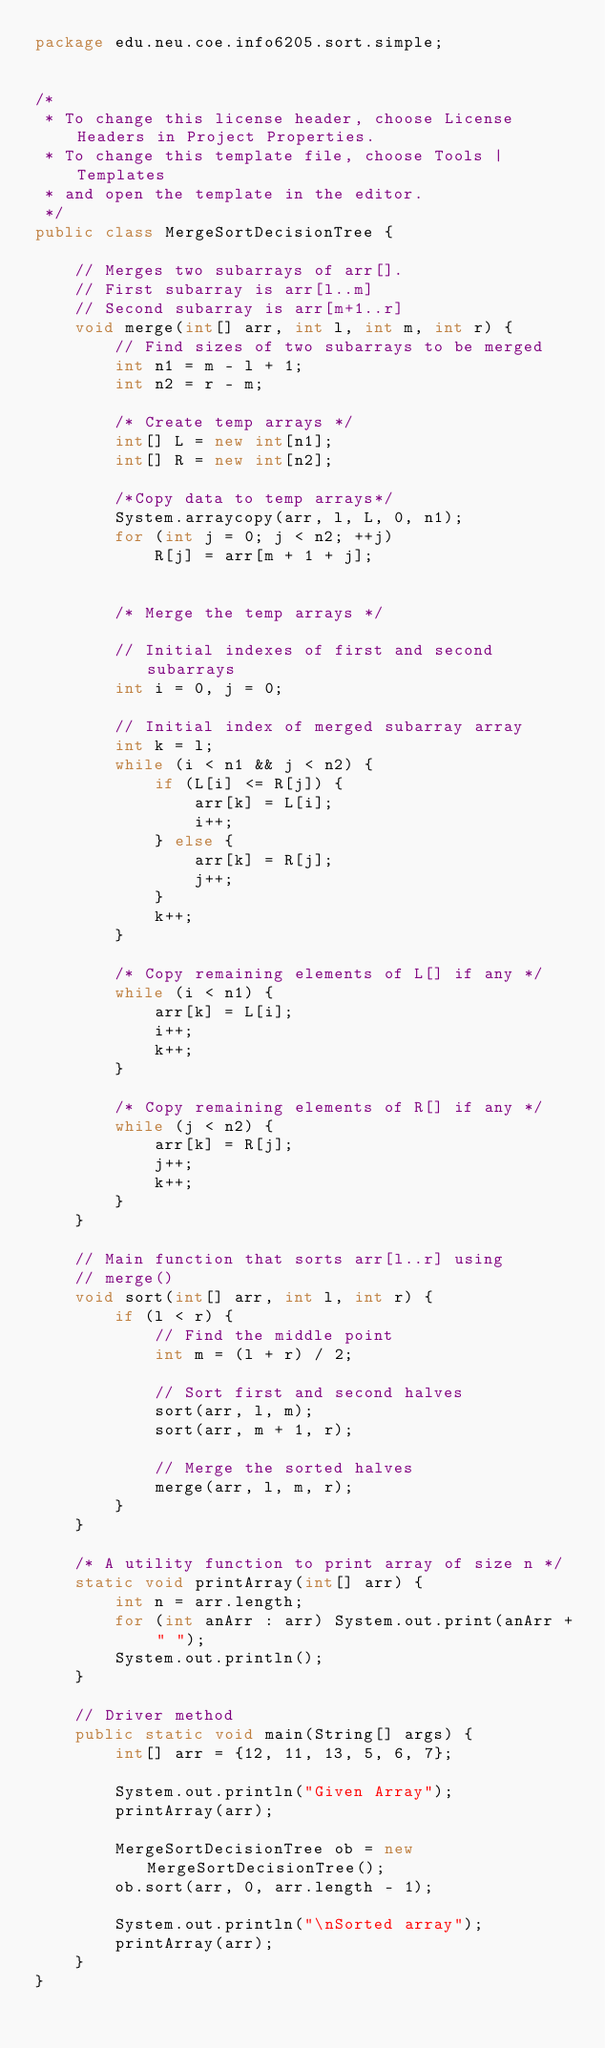<code> <loc_0><loc_0><loc_500><loc_500><_Java_>package edu.neu.coe.info6205.sort.simple;


/*
 * To change this license header, choose License Headers in Project Properties.
 * To change this template file, choose Tools | Templates
 * and open the template in the editor.
 */
public class MergeSortDecisionTree {

    // Merges two subarrays of arr[].
    // First subarray is arr[l..m]
    // Second subarray is arr[m+1..r]
    void merge(int[] arr, int l, int m, int r) {
        // Find sizes of two subarrays to be merged
        int n1 = m - l + 1;
        int n2 = r - m;

        /* Create temp arrays */
        int[] L = new int[n1];
        int[] R = new int[n2];

        /*Copy data to temp arrays*/
        System.arraycopy(arr, l, L, 0, n1);
        for (int j = 0; j < n2; ++j)
            R[j] = arr[m + 1 + j];


        /* Merge the temp arrays */

        // Initial indexes of first and second subarrays
        int i = 0, j = 0;

        // Initial index of merged subarray array
        int k = l;
        while (i < n1 && j < n2) {
            if (L[i] <= R[j]) {
                arr[k] = L[i];
                i++;
            } else {
                arr[k] = R[j];
                j++;
            }
            k++;
        }

        /* Copy remaining elements of L[] if any */
        while (i < n1) {
            arr[k] = L[i];
            i++;
            k++;
        }

        /* Copy remaining elements of R[] if any */
        while (j < n2) {
            arr[k] = R[j];
            j++;
            k++;
        }
    }

    // Main function that sorts arr[l..r] using
    // merge()
    void sort(int[] arr, int l, int r) {
        if (l < r) {
            // Find the middle point
            int m = (l + r) / 2;

            // Sort first and second halves
            sort(arr, l, m);
            sort(arr, m + 1, r);

            // Merge the sorted halves
            merge(arr, l, m, r);
        }
    }

    /* A utility function to print array of size n */
    static void printArray(int[] arr) {
        int n = arr.length;
        for (int anArr : arr) System.out.print(anArr + " ");
        System.out.println();
    }

    // Driver method
    public static void main(String[] args) {
        int[] arr = {12, 11, 13, 5, 6, 7};

        System.out.println("Given Array");
        printArray(arr);

        MergeSortDecisionTree ob = new MergeSortDecisionTree();
        ob.sort(arr, 0, arr.length - 1);

        System.out.println("\nSorted array");
        printArray(arr);
    }
}</code> 